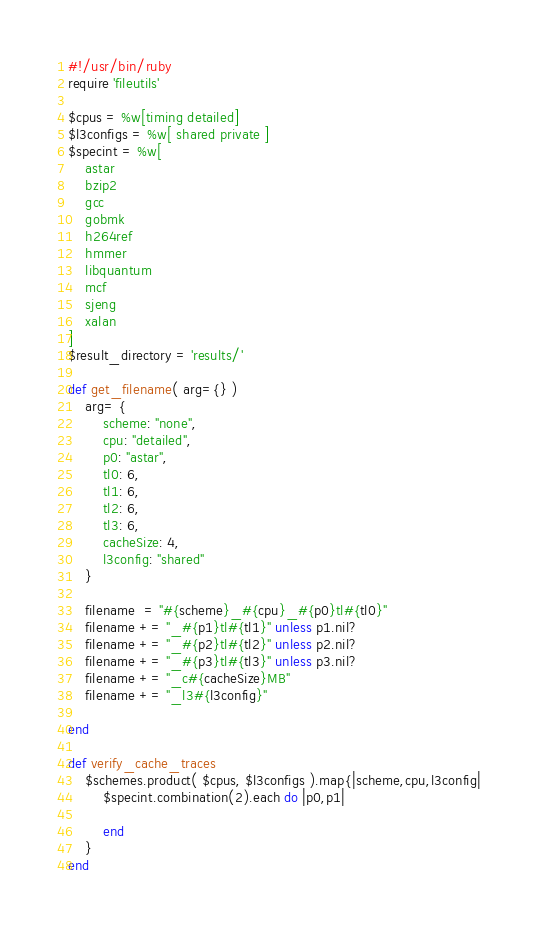<code> <loc_0><loc_0><loc_500><loc_500><_Ruby_>#!/usr/bin/ruby
require 'fileutils'

$cpus = %w[timing detailed]
$l3configs = %w[ shared private ]
$specint = %w[
    astar
    bzip2
    gcc
    gobmk
    h264ref
    hmmer
    libquantum
    mcf
    sjeng
    xalan
]
$result_directory = 'results/'

def get_filename( arg={} )
    arg= {
        scheme: "none",
        cpu: "detailed",
        p0: "astar",
        tl0: 6,
        tl1: 6,
        tl2: 6,
        tl3: 6,
        cacheSize: 4,
        l3config: "shared"
    }

    filename  = "#{scheme}_#{cpu}_#{p0}tl#{tl0}"
    filename += "_#{p1}tl#{tl1}" unless p1.nil?
    filename += "_#{p2}tl#{tl2}" unless p2.nil?
    filename += "_#{p3}tl#{tl3}" unless p3.nil?
    filename += "_c#{cacheSize}MB"
    filename += "_l3#{l3config}"

end

def verify_cache_traces
    $schemes.product( $cpus, $l3configs ).map{|scheme,cpu,l3config|
        $specint.combination(2).each do |p0,p1|

        end
    }
end
</code> 